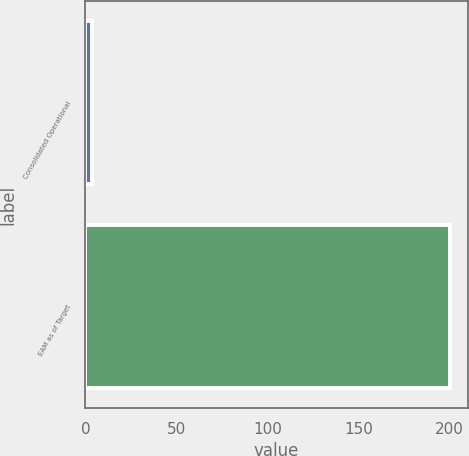<chart> <loc_0><loc_0><loc_500><loc_500><bar_chart><fcel>Consolidated Operational<fcel>EAM as of Target<nl><fcel>3.4<fcel>200<nl></chart> 